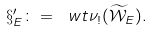Convert formula to latex. <formula><loc_0><loc_0><loc_500><loc_500>\S ^ { \prime } _ { E } \colon = \ w t { \nu } _ { ! } ( \widetilde { \mathcal { W } } _ { E } ) .</formula> 